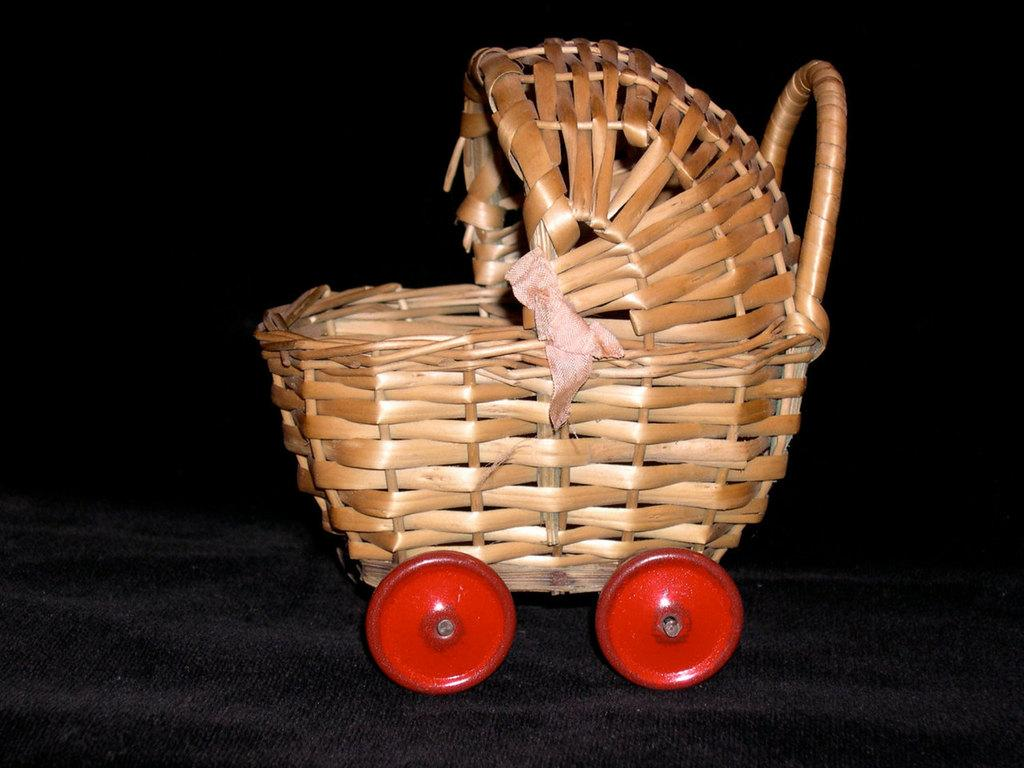What type of object is made of wicker in the image? There is a wicker object in the image. What feature does the wicker object have? The wicker object has wheels. What color are the wheels on the wicker object? The wheels are in red color. Can you see any jam on the wheels of the wicker object in the image? There is no jam present on the wheels of the wicker object in the image. 